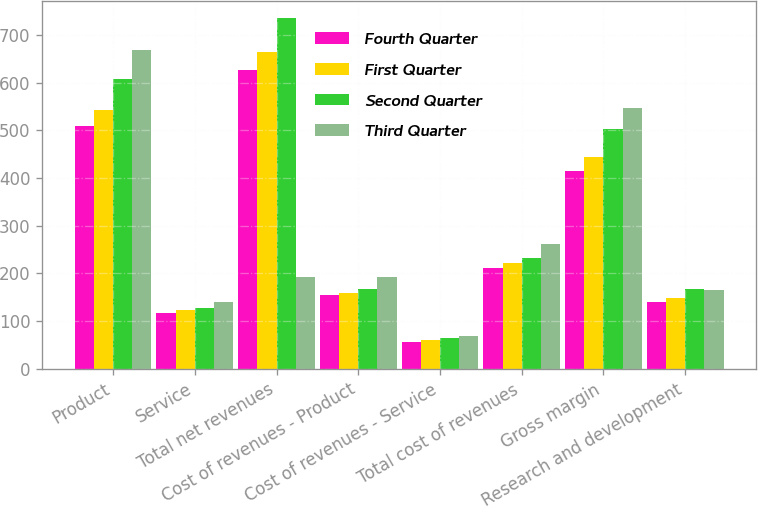Convert chart to OTSL. <chart><loc_0><loc_0><loc_500><loc_500><stacked_bar_chart><ecel><fcel>Product<fcel>Service<fcel>Total net revenues<fcel>Cost of revenues - Product<fcel>Cost of revenues - Service<fcel>Total cost of revenues<fcel>Gross margin<fcel>Research and development<nl><fcel>Fourth Quarter<fcel>509.8<fcel>117.1<fcel>626.9<fcel>154.9<fcel>57.2<fcel>212.1<fcel>414.8<fcel>141.1<nl><fcel>First Quarter<fcel>541.7<fcel>123.2<fcel>664.9<fcel>159.9<fcel>60.9<fcel>220.8<fcel>444.1<fcel>148.7<nl><fcel>Second Quarter<fcel>606.8<fcel>128.3<fcel>735.1<fcel>168.1<fcel>64.2<fcel>232.3<fcel>502.8<fcel>167.9<nl><fcel>Third Quarter<fcel>668.7<fcel>140.5<fcel>193.3<fcel>193.3<fcel>69.2<fcel>262.5<fcel>546.7<fcel>165.3<nl></chart> 